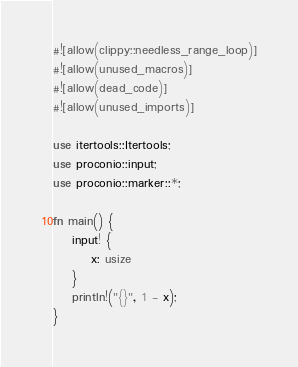<code> <loc_0><loc_0><loc_500><loc_500><_Rust_>#![allow(clippy::needless_range_loop)]
#![allow(unused_macros)]
#![allow(dead_code)]
#![allow(unused_imports)]

use itertools::Itertools;
use proconio::input;
use proconio::marker::*;

fn main() {
    input! {
        x: usize
    }
    println!("{}", 1 - x);
}
</code> 